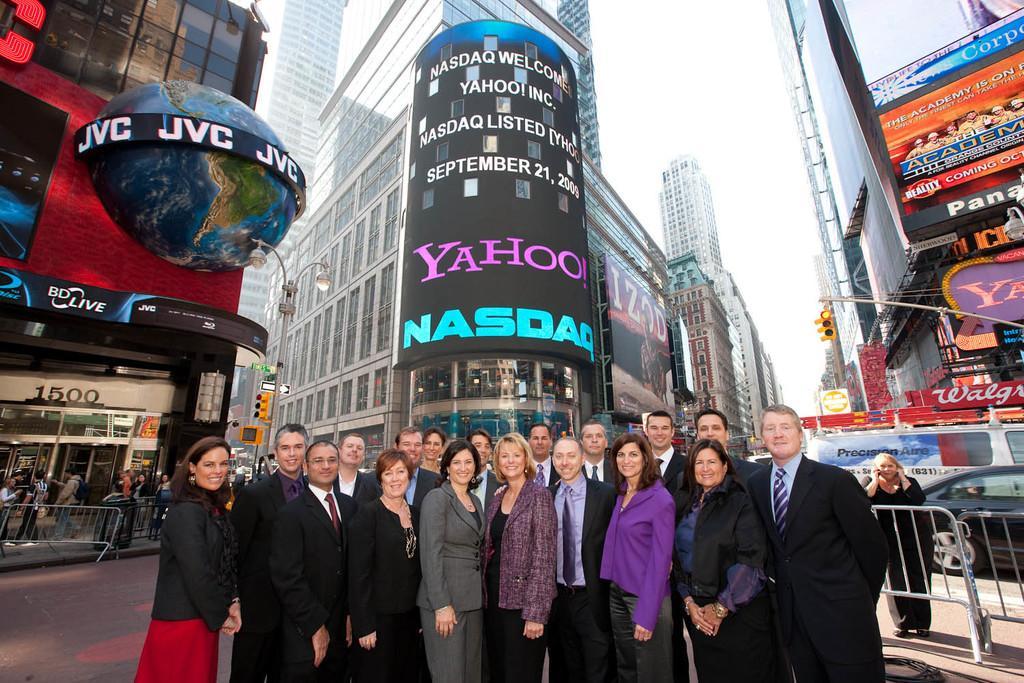How would you summarize this image in a sentence or two? In this picture we can see some people are standing in the front, on the right side and left side there are barricades, in the background we can see buildings, there are some boards, poles and traffic lights in the middle, there is the sky at the top of the picture. 